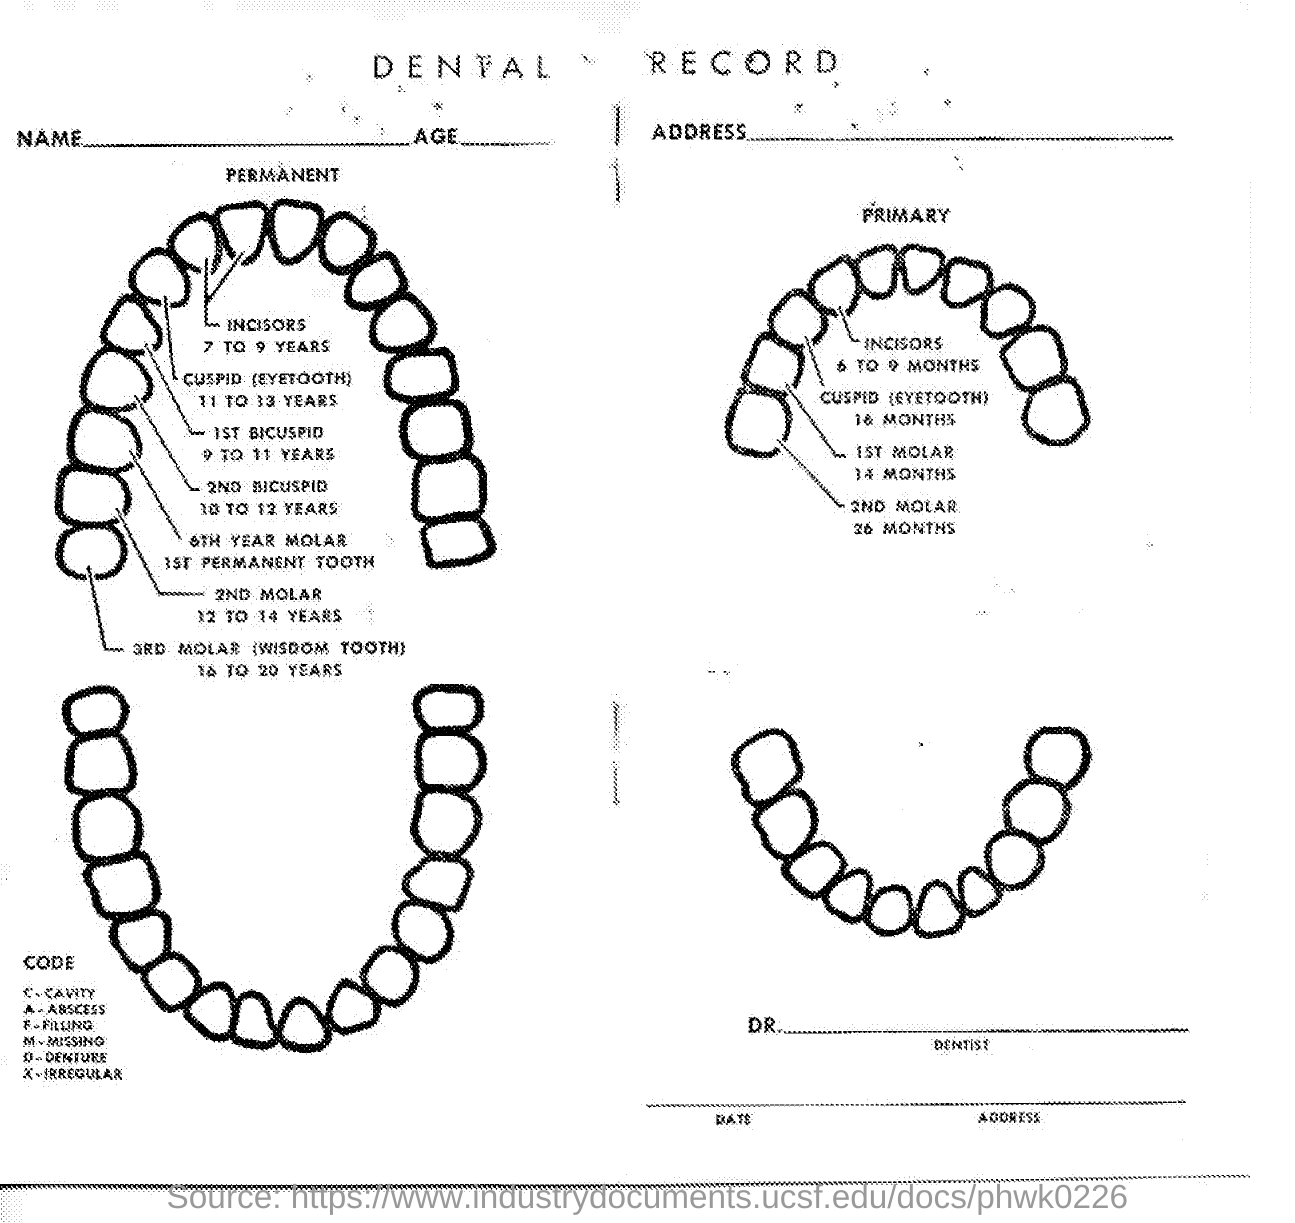What is the document title?
Offer a terse response. DENTAL RECORD. When do the incisors come for permanent teeth?
Offer a terse response. 7 TO 9 YEARS. What is another name for 3RD MOLAR?
Your answer should be very brief. WISDOM TOOTH. 